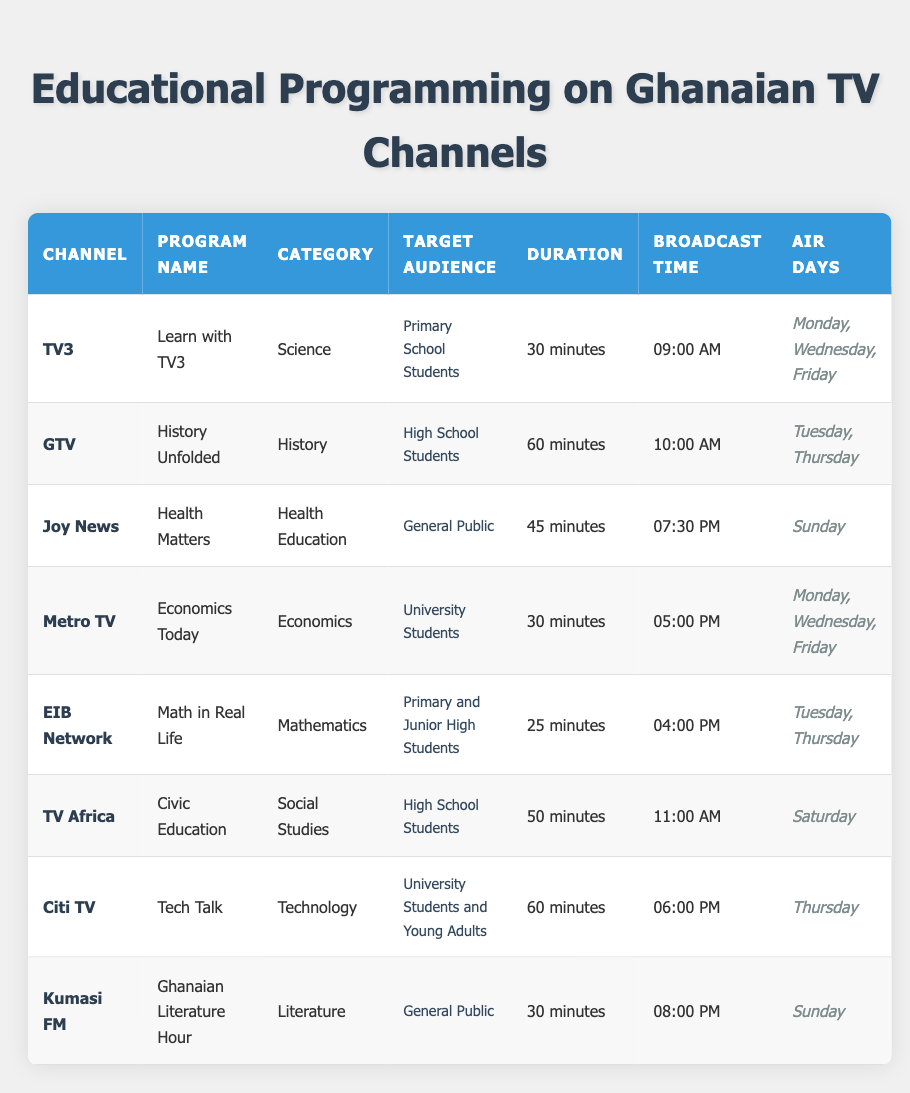What is the duration of the program "History Unfolded"? The program "History Unfolded" is listed under the GTV channel, and its corresponding duration is shown in the table as 60 minutes.
Answer: 60 minutes Which educational program targets primary school students? The table shows that "Learn with TV3" on TV3 is aimed at primary school students.
Answer: Learn with TV3 Is there a program that airs on Sunday? Looking through the table, both "Health Matters" on Joy News and "Ghanaian Literature Hour" on Kumasi FM are scheduled to air on Sunday.
Answer: Yes What is the broadcast time for the program "Tech Talk"? Referring to the table, "Tech Talk" on Citi TV has a broadcast time listed as 06:00 PM.
Answer: 06:00 PM Which channel has the longest duration of educational programming? Evaluating the durations listed, "GTV" has the "History Unfolded" program at 60 minutes and "Citi TV" has "Tech Talk" also at 60 minutes, both tied for the longest duration.
Answer: GTV and Citi TV How many programs are aimed at university students? Analyzing the table, "Economics Today" on Metro TV and "Tech Talk" on Citi TV are the two programs specifically targeting university students. Therefore, the total is 2.
Answer: 2 Which program offers civic education and what is its duration? The program "Civic Education" on TV Africa provides civic education, and according to the table, its duration is stated as 50 minutes.
Answer: Civic Education, 50 minutes What is the average duration of the educational programs listed? First, we sum the durations: 30 + 60 + 45 + 30 + 25 + 50 + 60 + 30 = 330 minutes. Since there are 8 programs, the average is calculated as 330/8 = 41.25 minutes.
Answer: 41.25 minutes Does "Math in Real Life" air on a weekend? Looking at the air days for "Math in Real Life," they include Tuesday and Thursday, which do not fall on the weekend. Therefore, this statement is false.
Answer: No Which program has the narrowest target audience? The program "Learn with TV3" specifies its target audience as "Primary School Students," making it more narrowly focused compared to other programs with broader audience segments.
Answer: Learn with TV3 